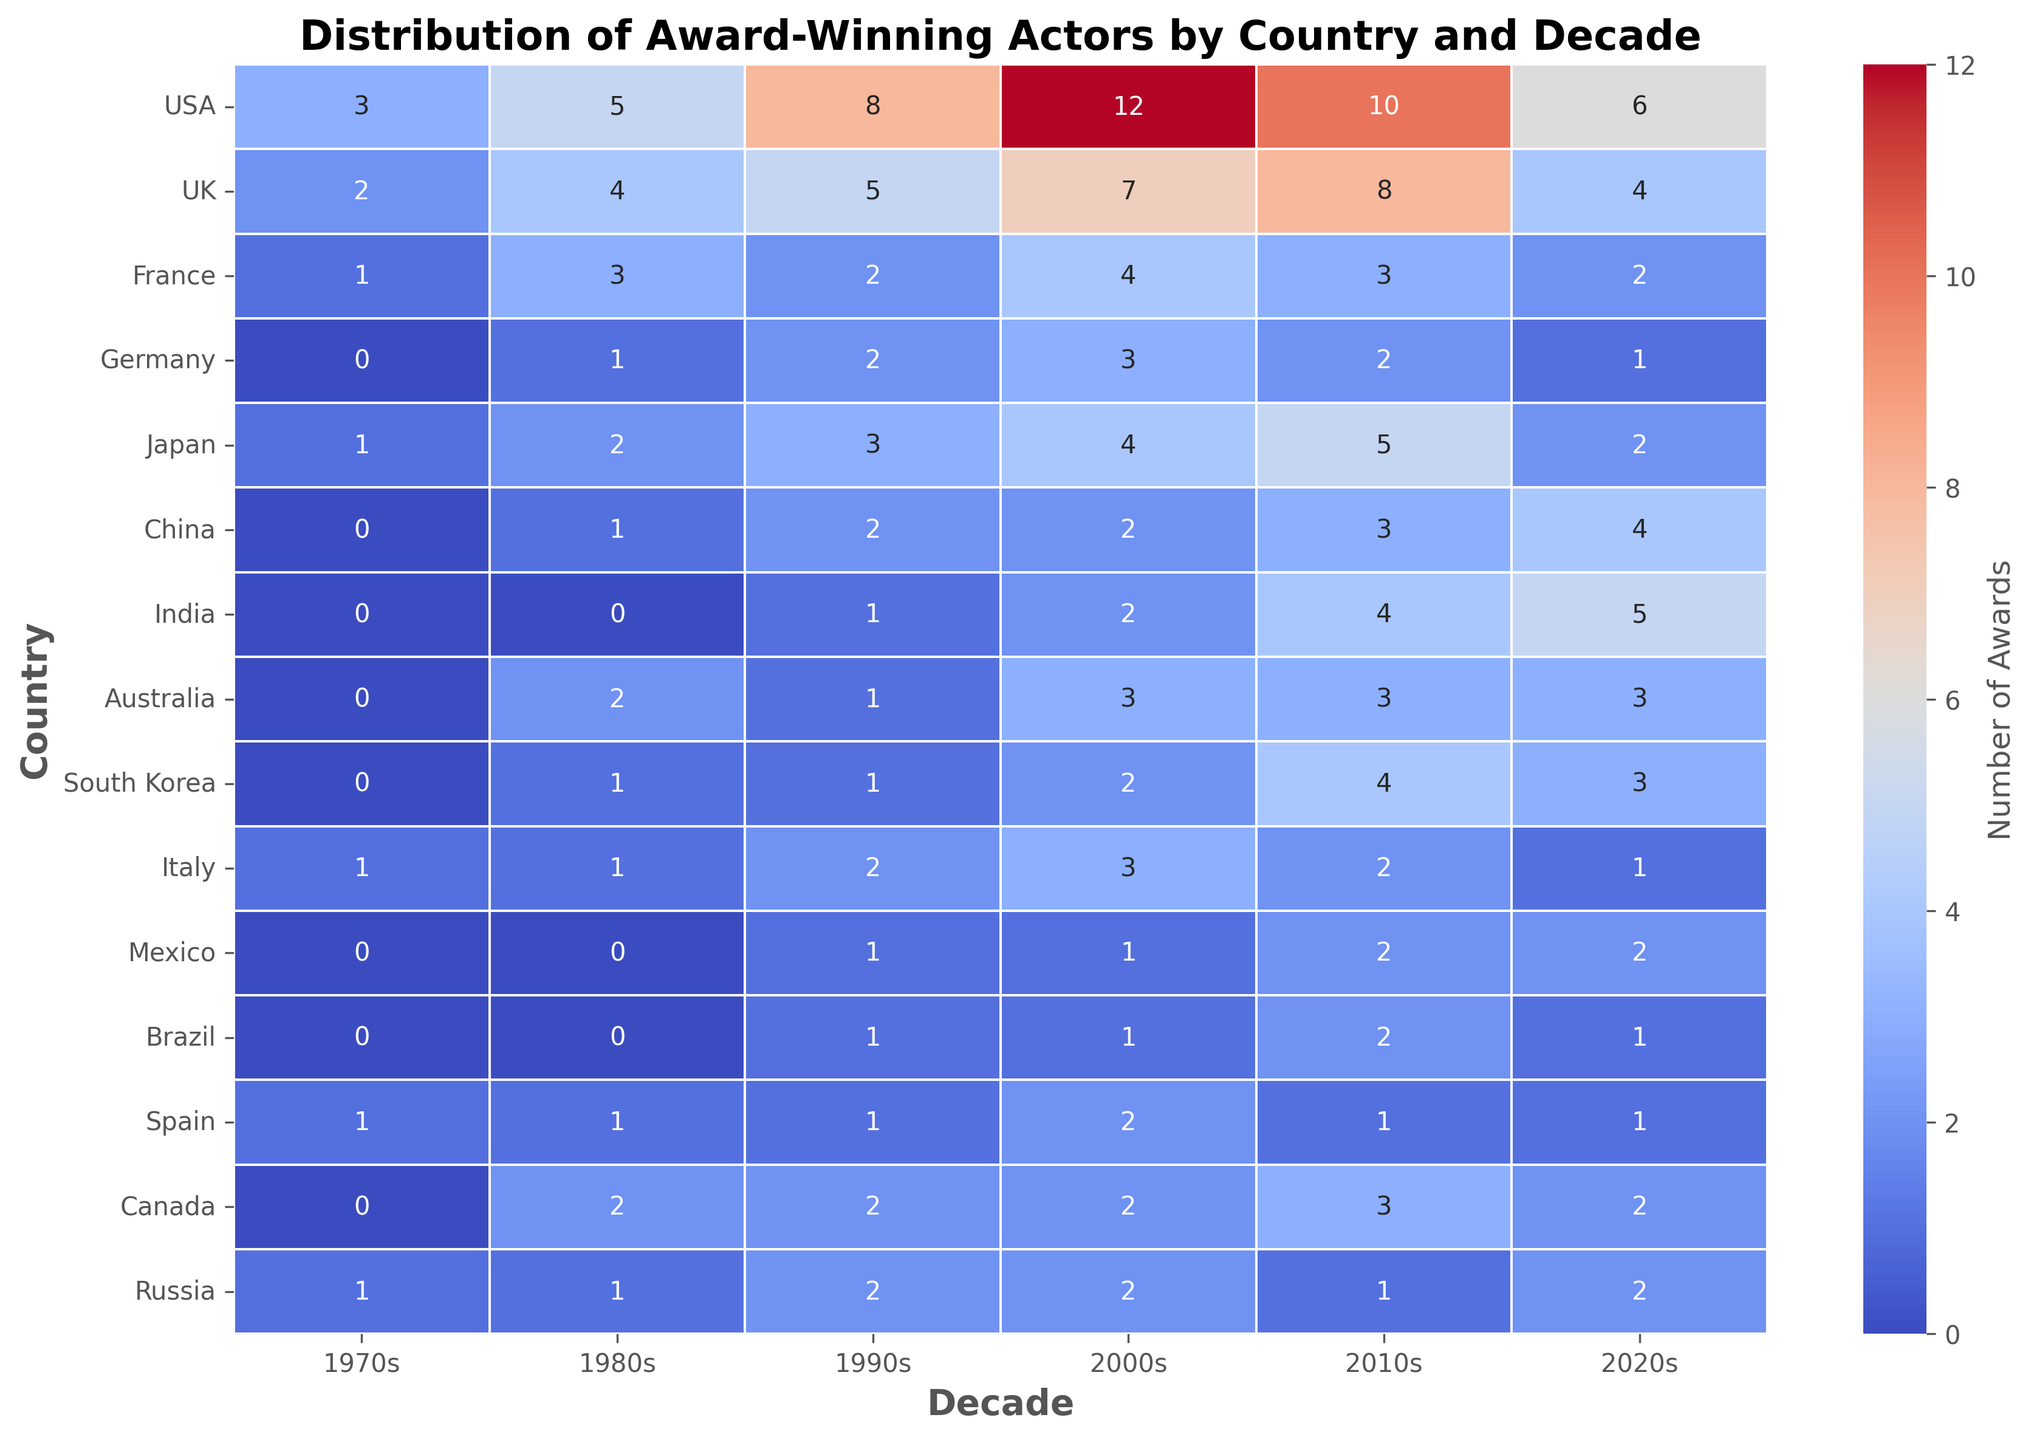What country had the highest number of award-winning actors in the 2000s? Look at the 2000s column and identify the country with the highest number. The USA has 12 award-winning actors.
Answer: USA Which two decades saw the greatest increase in award-winning actors for India? Compare the number of awards across the decades for India. The largest increase is from the 2000s to the 2010s (2 to 4) and from the 2010s to the 2020s (4 to 5).
Answer: 2000s to 2010s and 2010s to 2020s How many more awards did the USA win in the 1990s compared to Japan? Look at the values for the 1990s for both the USA (8) and Japan (3), then subtract Japan’s value from the USA’s. 8 - 3 = 5.
Answer: 5 Which country had a decreasing trend in the number of award-winning actors from the 2000s to the 2020s? Examine the numbers for each country from the 2000s to the 2020s. Only France shows a decreasing trend (4, 3, 2).
Answer: France What is the total number of awards won by UK actors from the 1970s to the 2020s? Add the numbers for the UK across all decades: 2 (1970s) + 4 (1980s) + 5 (1990s) + 7 (2000s) + 8 (2010s) + 4 (2020s) = 30.
Answer: 30 Which country had the least number of award-winning actors in the 1970s? Look at the 1970s column and find the minimum value which is shared by Germany, China, India, Australia, South Korea, Mexico, Brazil, and Canada all with 0 awards.
Answer: Germany, China, India, Australia, South Korea, Mexico, Brazil, Canada In which decade did Canada experience the highest number of award-winning actors? Look at the row for Canada and identify the highest value across the decades, which is the 2010s with 3 awards.
Answer: 2010s How many total award-winning actors are there from South Korea in the dataset? Add the values for South Korea across all decades: 0 (1970s) + 1 (1980s) + 1 (1990s) + 2 (2000s) + 4 (2010s) + 3 (2020s) = 11.
Answer: 11 What country's award count in the 2020s equals Japan’s award count in the 1980s? Japan’s award count in the 1980s is 2. Locate the country with 2 awards in the 2020s, and both France and Canada meet this criterion.
Answer: France and Canada How does the number of award-winning actors in Italy compare to Mexico in the 2010s? Compare the numbers in the 2010s column: Italy has 2 and Mexico has 2 as well. Therefore, they are equal.
Answer: They are equal 